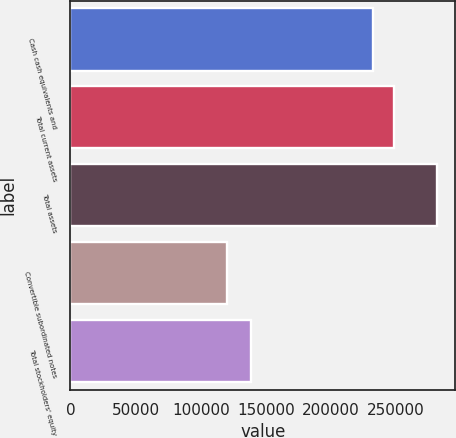Convert chart to OTSL. <chart><loc_0><loc_0><loc_500><loc_500><bar_chart><fcel>Cash cash equivalents and<fcel>Total current assets<fcel>Total assets<fcel>Convertible subordinated notes<fcel>Total stockholders' equity<nl><fcel>232498<fcel>248620<fcel>281221<fcel>120000<fcel>138505<nl></chart> 